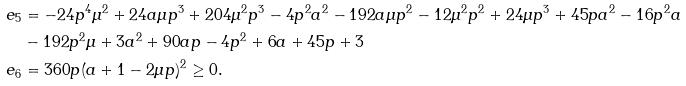<formula> <loc_0><loc_0><loc_500><loc_500>e _ { 5 } & = - 2 4 p ^ { 4 } \mu ^ { 2 } + 2 4 a \mu p ^ { 3 } + 2 0 4 \mu ^ { 2 } p ^ { 3 } - 4 p ^ { 2 } a ^ { 2 } - 1 9 2 a \mu p ^ { 2 } - 1 2 \mu ^ { 2 } p ^ { 2 } + 2 4 \mu p ^ { 3 } + 4 5 p a ^ { 2 } - 1 6 p ^ { 2 } a \\ & - 1 9 2 p ^ { 2 } \mu + 3 a ^ { 2 } + 9 0 a p - 4 p ^ { 2 } + 6 a + 4 5 p + 3 \\ e _ { 6 } & = 3 6 0 p ( a + 1 - 2 \mu p ) ^ { 2 } \geq 0 .</formula> 